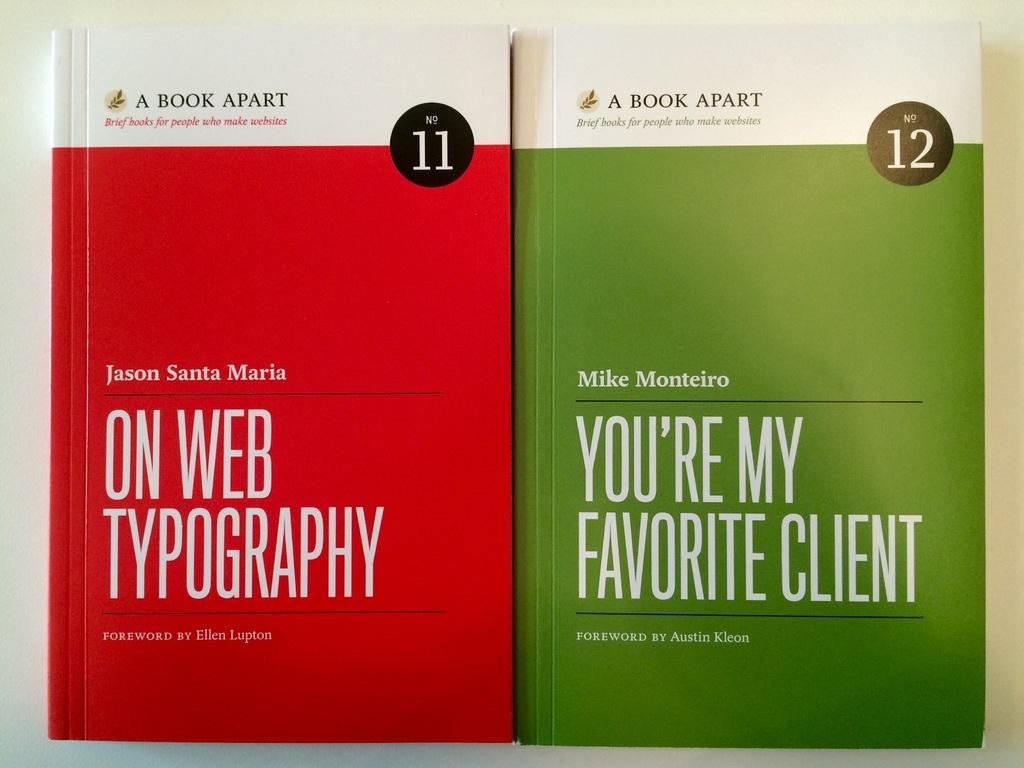How would you summarize this image in a sentence or two? In this image we can see two books placed on the surface. 